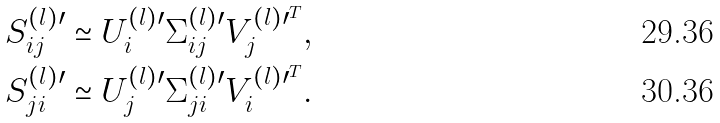<formula> <loc_0><loc_0><loc_500><loc_500>S ^ { ( l ) \prime } _ { i j } & \simeq U ^ { ( l ) \prime } _ { i } \Sigma ^ { ( l ) \prime } _ { i j } V ^ { ( l ) \prime ^ { T } } _ { j } , \\ S ^ { ( l ) \prime } _ { j i } & \simeq U ^ { ( l ) \prime } _ { j } \Sigma ^ { ( l ) \prime } _ { j i } V ^ { ( l ) \prime ^ { T } } _ { i } .</formula> 